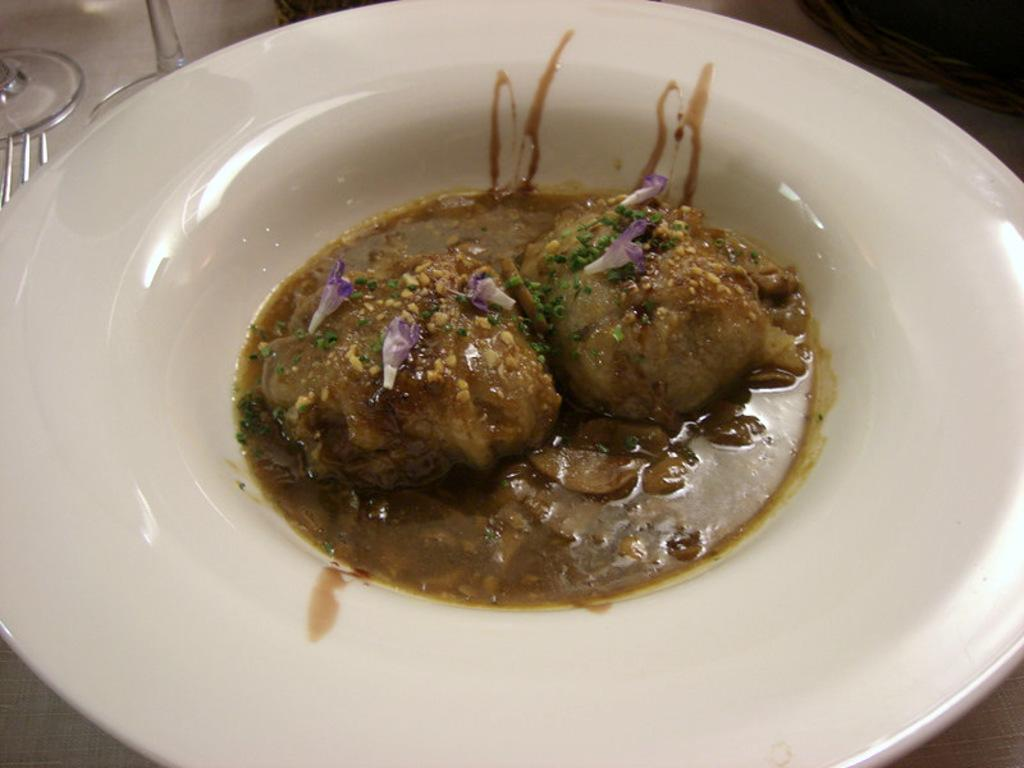What is on the plate in the image? There is food in the plate in the image. What can be seen in the background of the image? There are glasses and a fork in the background of the image. What type of pin is visible on the food in the image? There is no pin present on the food in the image. 